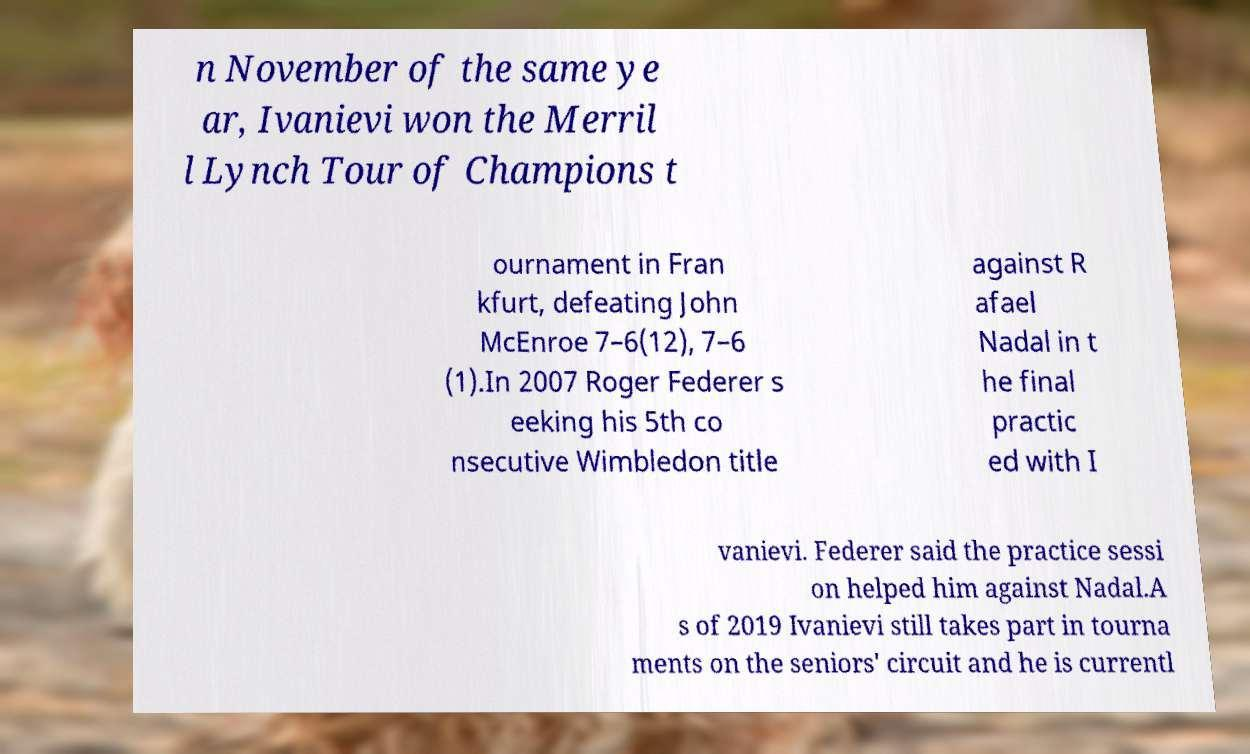Please read and relay the text visible in this image. What does it say? n November of the same ye ar, Ivanievi won the Merril l Lynch Tour of Champions t ournament in Fran kfurt, defeating John McEnroe 7–6(12), 7–6 (1).In 2007 Roger Federer s eeking his 5th co nsecutive Wimbledon title against R afael Nadal in t he final practic ed with I vanievi. Federer said the practice sessi on helped him against Nadal.A s of 2019 Ivanievi still takes part in tourna ments on the seniors' circuit and he is currentl 